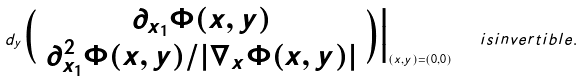<formula> <loc_0><loc_0><loc_500><loc_500>d _ { y } \Big ( \begin{array} { c } \partial _ { x _ { 1 } } \Phi ( x , y ) \\ \partial ^ { 2 } _ { x _ { 1 } } \Phi ( x , y ) / | \nabla _ { x } \Phi ( x , y ) | \end{array} \Big ) \Big | _ { ( x , y ) = ( 0 , 0 ) } \quad i s i n v e r t i b l e .</formula> 